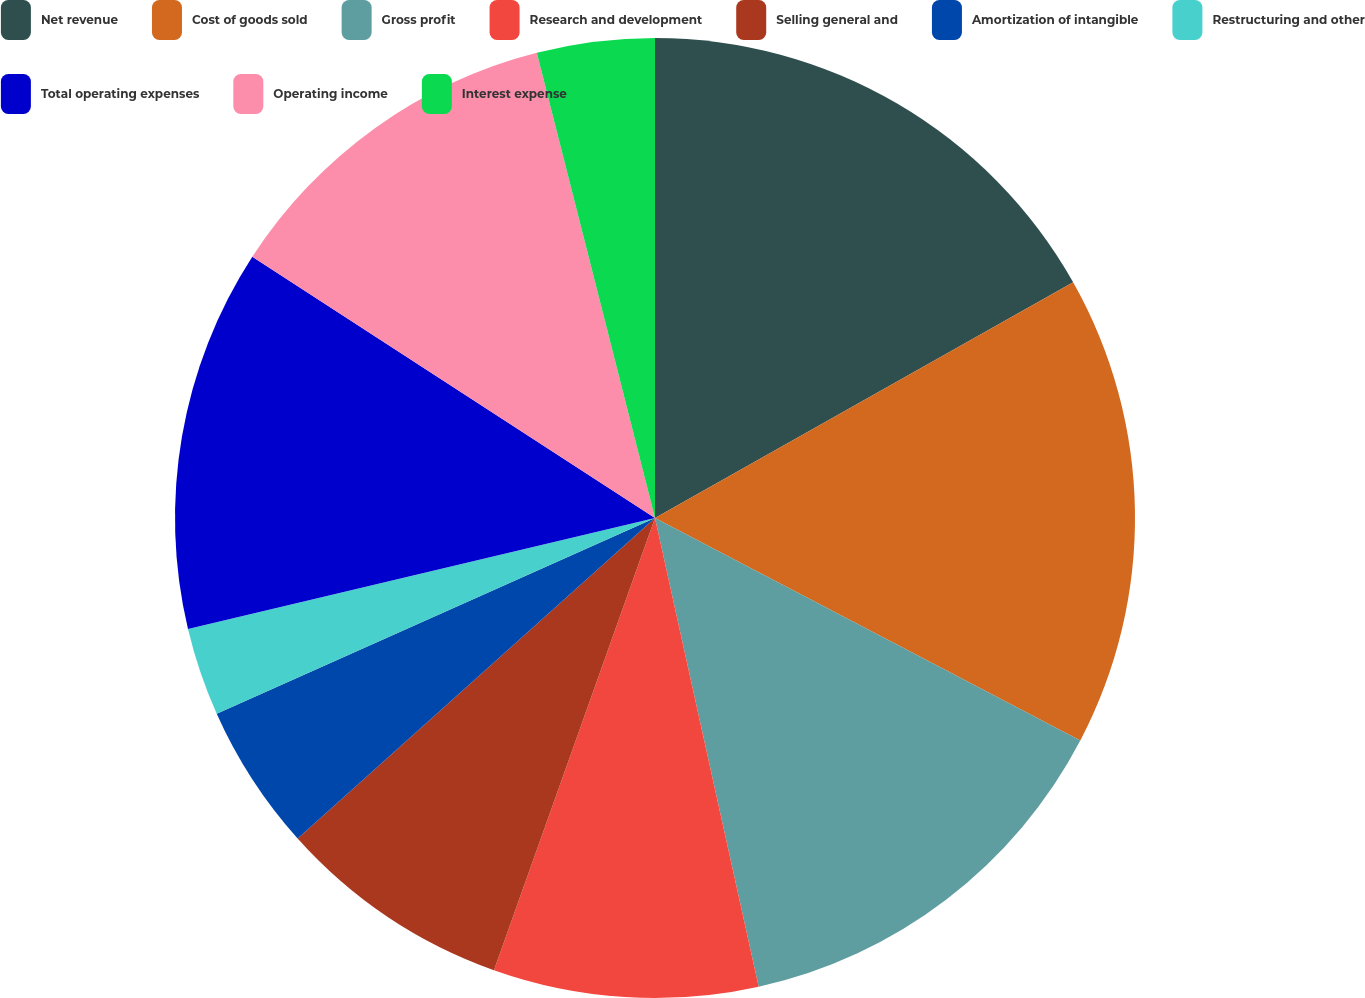<chart> <loc_0><loc_0><loc_500><loc_500><pie_chart><fcel>Net revenue<fcel>Cost of goods sold<fcel>Gross profit<fcel>Research and development<fcel>Selling general and<fcel>Amortization of intangible<fcel>Restructuring and other<fcel>Total operating expenses<fcel>Operating income<fcel>Interest expense<nl><fcel>16.83%<fcel>15.84%<fcel>13.86%<fcel>8.91%<fcel>7.92%<fcel>4.95%<fcel>2.97%<fcel>12.87%<fcel>11.88%<fcel>3.96%<nl></chart> 